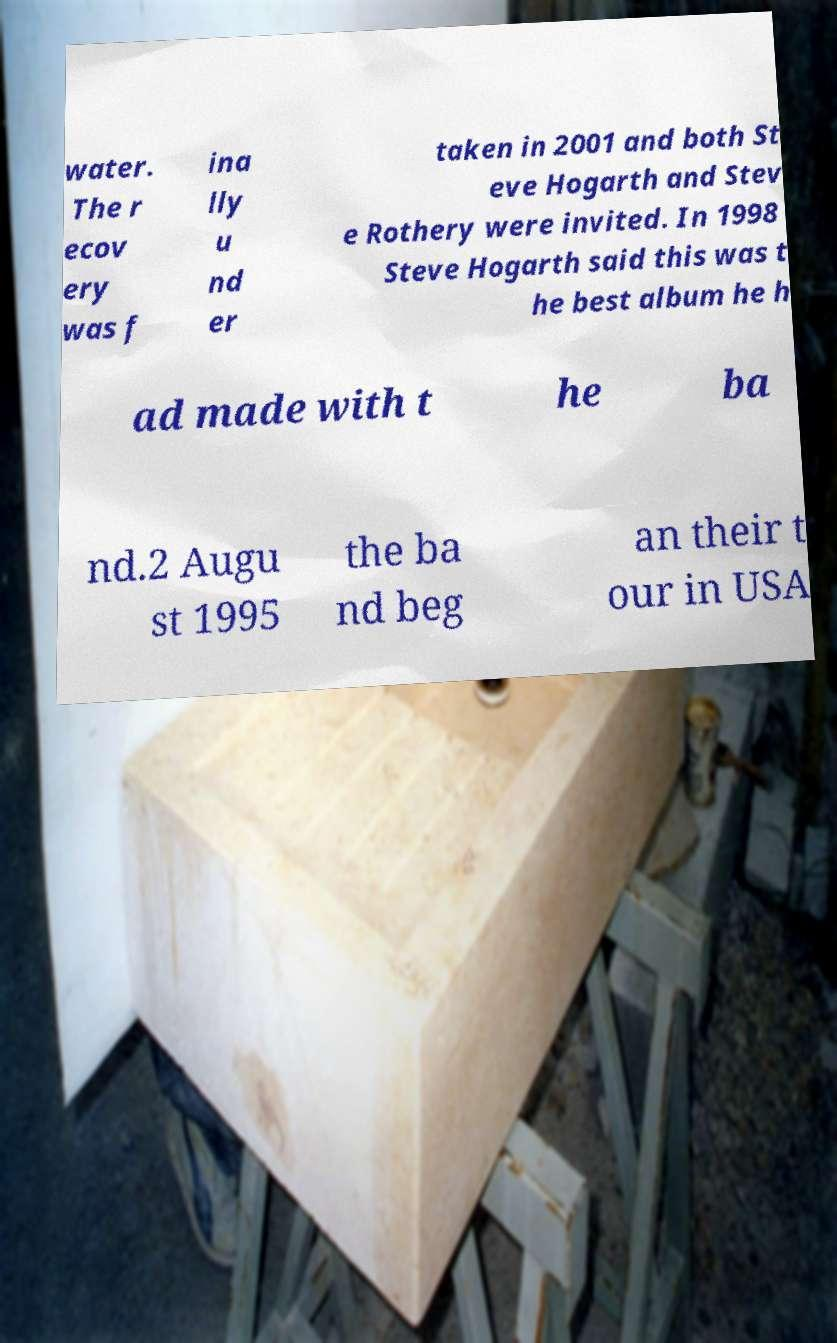Can you read and provide the text displayed in the image?This photo seems to have some interesting text. Can you extract and type it out for me? water. The r ecov ery was f ina lly u nd er taken in 2001 and both St eve Hogarth and Stev e Rothery were invited. In 1998 Steve Hogarth said this was t he best album he h ad made with t he ba nd.2 Augu st 1995 the ba nd beg an their t our in USA 